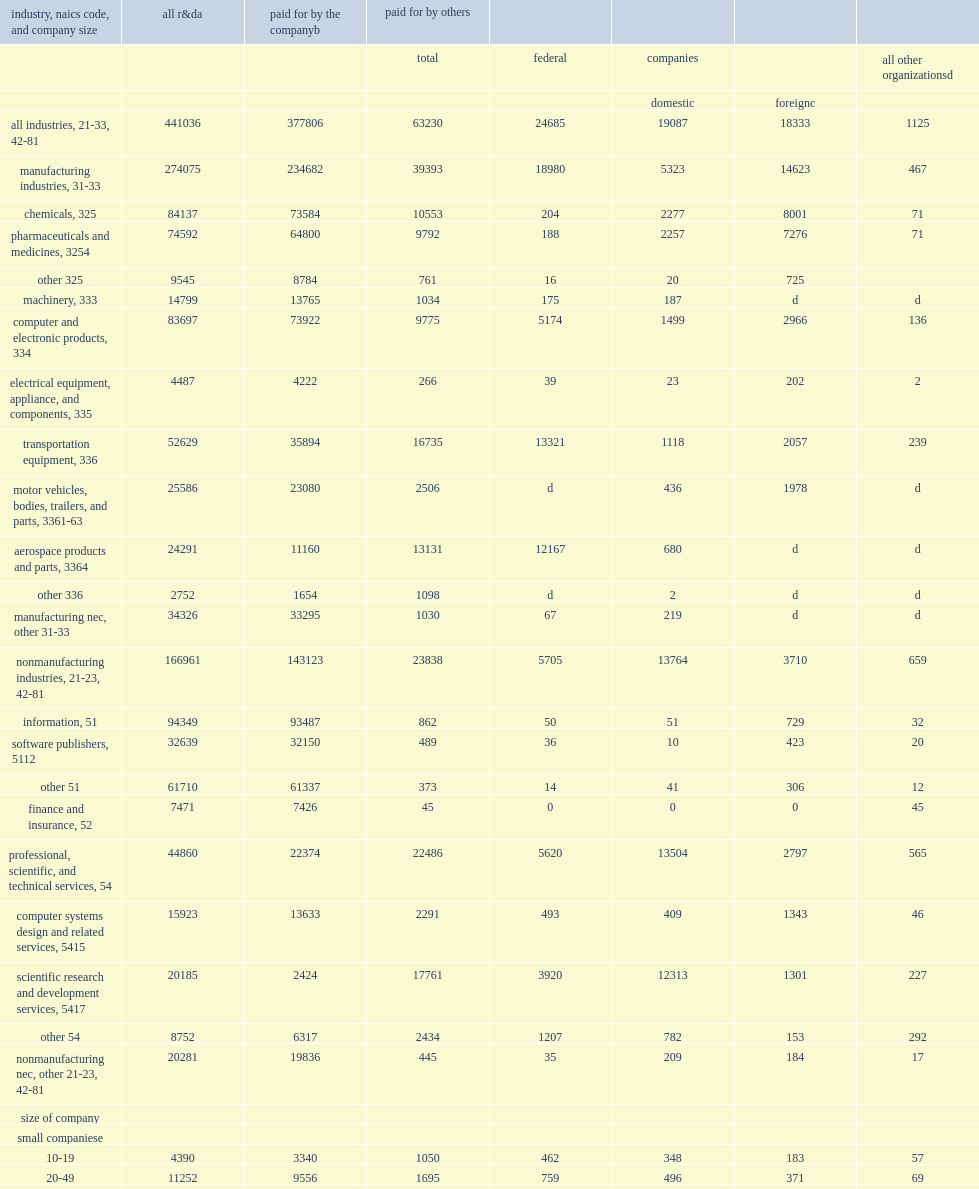In 2018, companies in manufacturing industries performed $274 million of domestic r&d, defined as r&d performed in the 50 states and washington, dc. 274075.0. How many million dollars did companies in nonmanufacturing industries perform of total domestic r&d performance? 166961.0. 